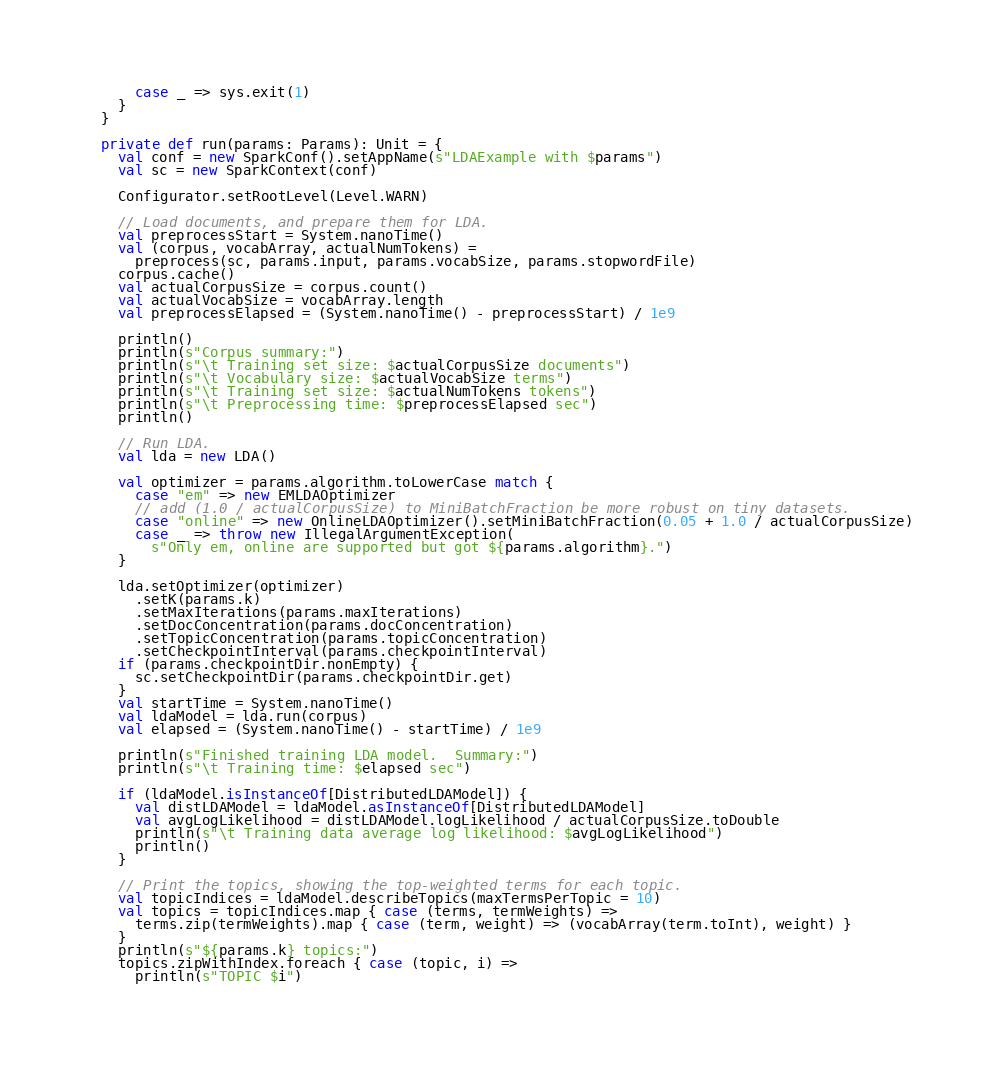<code> <loc_0><loc_0><loc_500><loc_500><_Scala_>      case _ => sys.exit(1)
    }
  }

  private def run(params: Params): Unit = {
    val conf = new SparkConf().setAppName(s"LDAExample with $params")
    val sc = new SparkContext(conf)

    Configurator.setRootLevel(Level.WARN)

    // Load documents, and prepare them for LDA.
    val preprocessStart = System.nanoTime()
    val (corpus, vocabArray, actualNumTokens) =
      preprocess(sc, params.input, params.vocabSize, params.stopwordFile)
    corpus.cache()
    val actualCorpusSize = corpus.count()
    val actualVocabSize = vocabArray.length
    val preprocessElapsed = (System.nanoTime() - preprocessStart) / 1e9

    println()
    println(s"Corpus summary:")
    println(s"\t Training set size: $actualCorpusSize documents")
    println(s"\t Vocabulary size: $actualVocabSize terms")
    println(s"\t Training set size: $actualNumTokens tokens")
    println(s"\t Preprocessing time: $preprocessElapsed sec")
    println()

    // Run LDA.
    val lda = new LDA()

    val optimizer = params.algorithm.toLowerCase match {
      case "em" => new EMLDAOptimizer
      // add (1.0 / actualCorpusSize) to MiniBatchFraction be more robust on tiny datasets.
      case "online" => new OnlineLDAOptimizer().setMiniBatchFraction(0.05 + 1.0 / actualCorpusSize)
      case _ => throw new IllegalArgumentException(
        s"Only em, online are supported but got ${params.algorithm}.")
    }

    lda.setOptimizer(optimizer)
      .setK(params.k)
      .setMaxIterations(params.maxIterations)
      .setDocConcentration(params.docConcentration)
      .setTopicConcentration(params.topicConcentration)
      .setCheckpointInterval(params.checkpointInterval)
    if (params.checkpointDir.nonEmpty) {
      sc.setCheckpointDir(params.checkpointDir.get)
    }
    val startTime = System.nanoTime()
    val ldaModel = lda.run(corpus)
    val elapsed = (System.nanoTime() - startTime) / 1e9

    println(s"Finished training LDA model.  Summary:")
    println(s"\t Training time: $elapsed sec")

    if (ldaModel.isInstanceOf[DistributedLDAModel]) {
      val distLDAModel = ldaModel.asInstanceOf[DistributedLDAModel]
      val avgLogLikelihood = distLDAModel.logLikelihood / actualCorpusSize.toDouble
      println(s"\t Training data average log likelihood: $avgLogLikelihood")
      println()
    }

    // Print the topics, showing the top-weighted terms for each topic.
    val topicIndices = ldaModel.describeTopics(maxTermsPerTopic = 10)
    val topics = topicIndices.map { case (terms, termWeights) =>
      terms.zip(termWeights).map { case (term, weight) => (vocabArray(term.toInt), weight) }
    }
    println(s"${params.k} topics:")
    topics.zipWithIndex.foreach { case (topic, i) =>
      println(s"TOPIC $i")</code> 